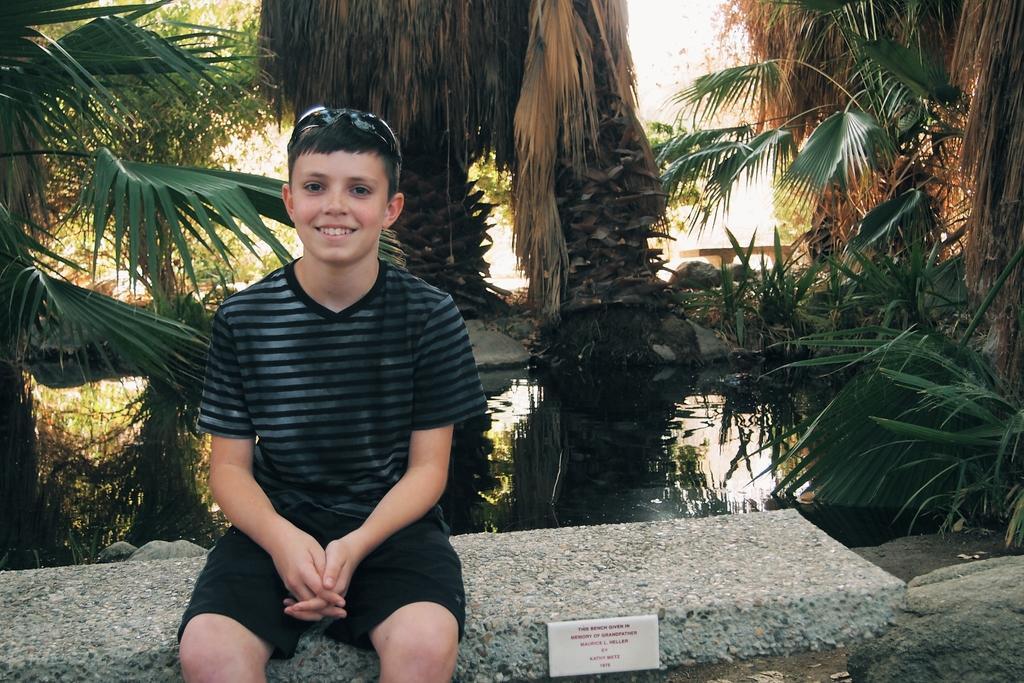Could you give a brief overview of what you see in this image? In the picture we can see a boy sitting on the marble bench and he is smiling, he is with gray color T-shirt and black lines on it and behind him we can see some plants and water and behind it we can see some trees. 